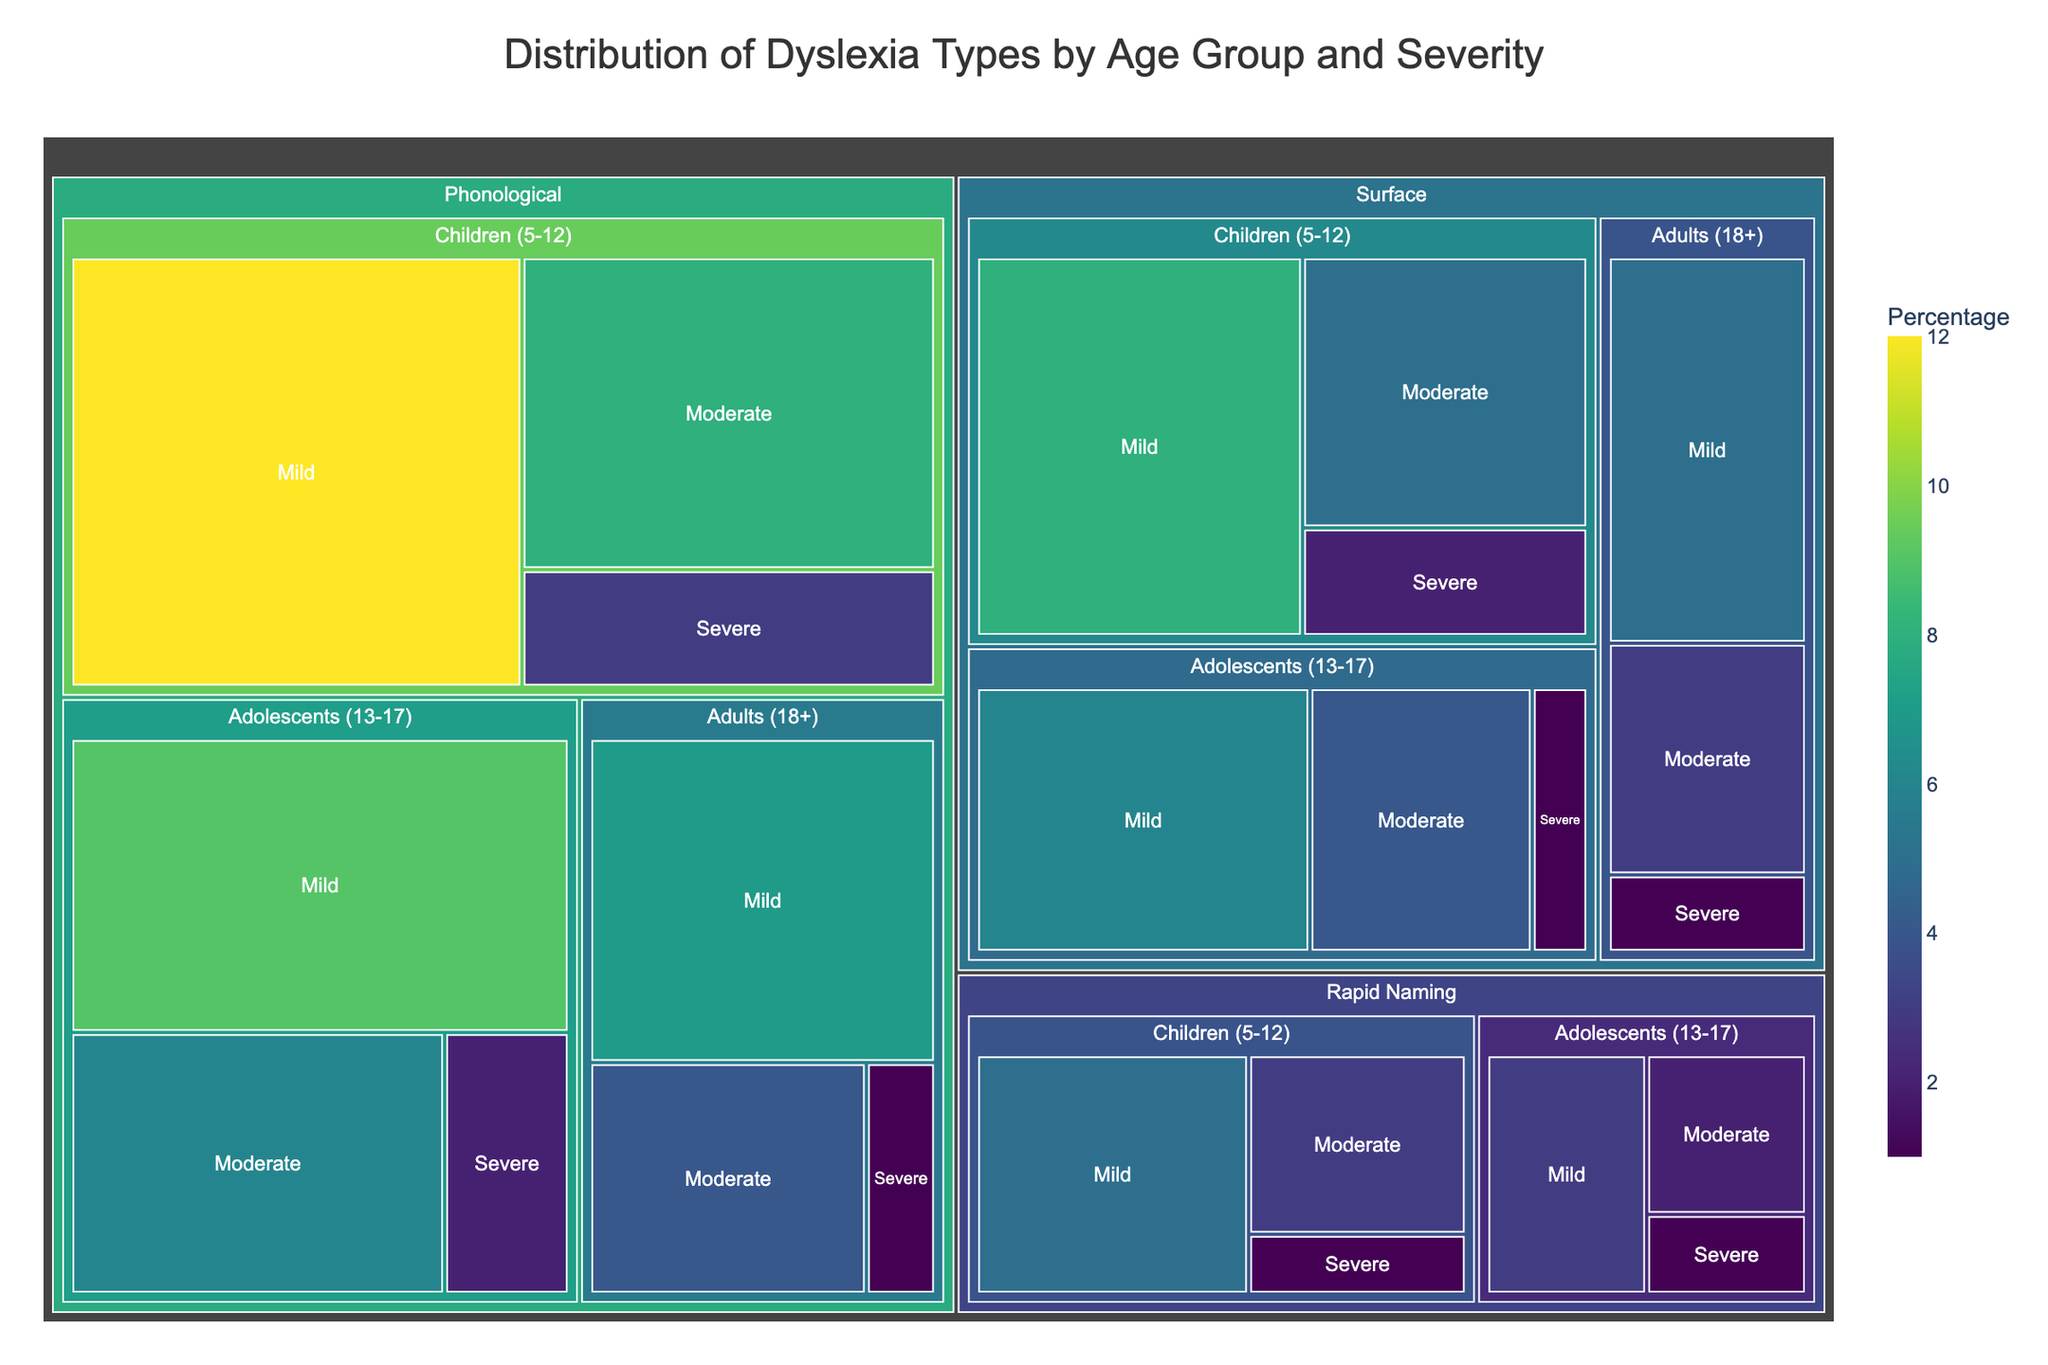What is the title of the figure? The title is located at the top of the figure.
Answer: Distribution of Dyslexia Types by Age Group and Severity Which age group has the highest percentage of individuals with mild phonological dyslexia? You need to look at the sections corresponding to the phonological dyslexia type and mild severity, then compare the age groups (Children, Adolescents, and Adults).
Answer: Children (5-12) What age group and severity combination has the lowest percentage for surface dyslexia? Identify the sections for surface dyslexia, then check each age group and their severities. The lowest percentage will be the smallest segment.
Answer: Severe, Adolescents (13-17) Compare the percentage of moderate phonological dyslexia in adolescents to adults. Which group has a higher percentage? Locate the sections for moderate phonological dyslexia and compare the values for adolescents and adults.
Answer: Adolescents (13-17) What is the total percentage of individuals diagnosed with mild dyslexia, irrespective of type and age group? Sum up the percentages of all sections labeled with mild severity across different types and age groups.
Answer: 52% Which subtype of dyslexia is most prevalent among adults with mild severity? Look at the sections corresponding to mild dyslexia in adults and identify which subtype has the largest percentage.
Answer: Phonological How does the percentage of severe rapid naming dyslexia in children compare to adolescents? Locate the sections for severe rapid naming dyslexia and compare the percentages between the two age groups.
Answer: Children (5-12) have a higher percentage What is the most common age group and severity combination for surface dyslexia? Find the age group and severity combination for surface dyslexia with the highest percentage.
Answer: Mild, Children (5-12) In terms of severity, which dyslexia type has the most balanced distribution across all age groups? Examine each dyslexia type's segments and compare the severity distributions across age groups. The most balanced will have relatively even percentages.
Answer: Rapid Naming 